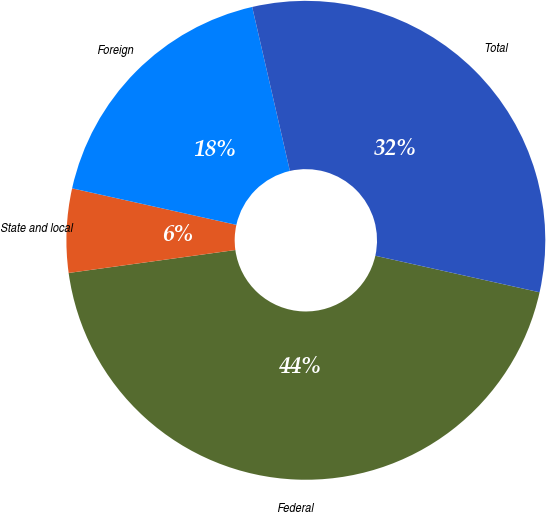Convert chart. <chart><loc_0><loc_0><loc_500><loc_500><pie_chart><fcel>Federal<fcel>State and local<fcel>Foreign<fcel>Total<nl><fcel>44.34%<fcel>5.66%<fcel>17.92%<fcel>32.08%<nl></chart> 